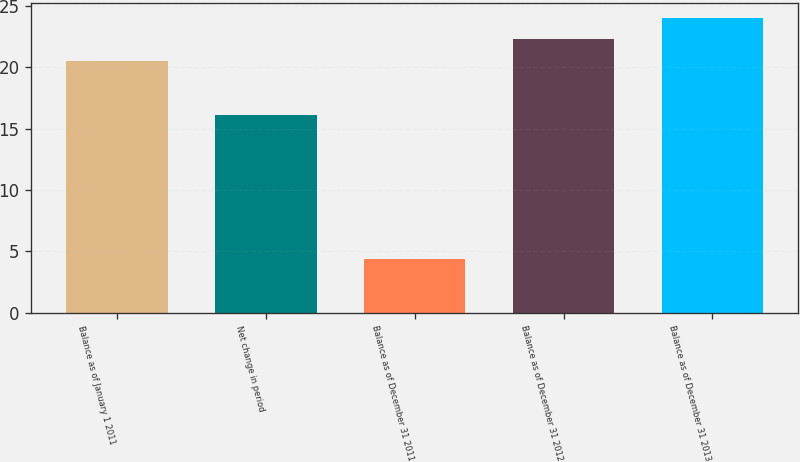<chart> <loc_0><loc_0><loc_500><loc_500><bar_chart><fcel>Balance as of January 1 2011<fcel>Net change in period<fcel>Balance as of December 31 2011<fcel>Balance as of December 31 2012<fcel>Balance as of December 31 2013<nl><fcel>20.5<fcel>16.1<fcel>4.4<fcel>22.27<fcel>24.04<nl></chart> 